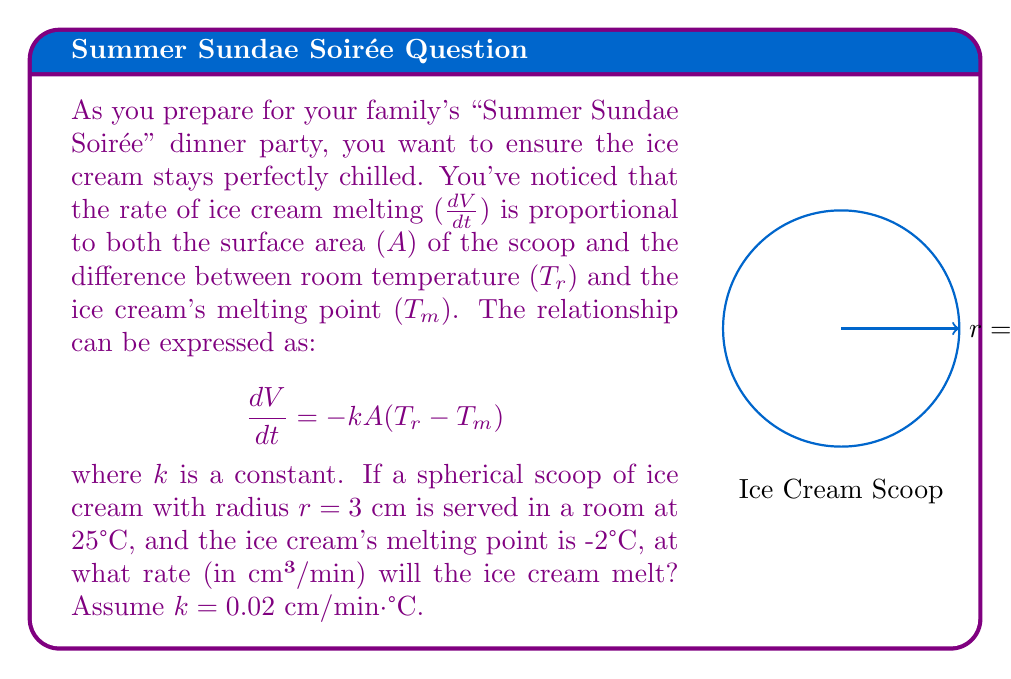Can you solve this math problem? Let's approach this step-by-step:

1) We're given the equation: $\frac{dV}{dt} = -k A (T_r - T_m)$

2) We need to find the surface area $A$ of the spherical scoop. The formula for the surface area of a sphere is $A = 4\pi r^2$:
   $A = 4\pi (3\text{ cm})^2 = 36\pi \text{ cm}^2$

3) We're given:
   $k = 0.02 \text{ cm/min·°C}$
   $T_r = 25°C$
   $T_m = -2°C$

4) Let's substitute these values into our equation:

   $\frac{dV}{dt} = -0.02 \text{ cm/min·°C} \cdot 36\pi \text{ cm}^2 \cdot (25°C - (-2°C))$

5) Simplify:
   $\frac{dV}{dt} = -0.02 \cdot 36\pi \cdot 27 \text{ cm}^3/\text{min}$
   $\frac{dV}{dt} = -19.44\pi \text{ cm}^3/\text{min}$

6) Calculate the final value:
   $\frac{dV}{dt} \approx -61.07 \text{ cm}^3/\text{min}$

The negative sign indicates that the volume is decreasing over time.
Answer: $61.07 \text{ cm}^3/\text{min}$ 